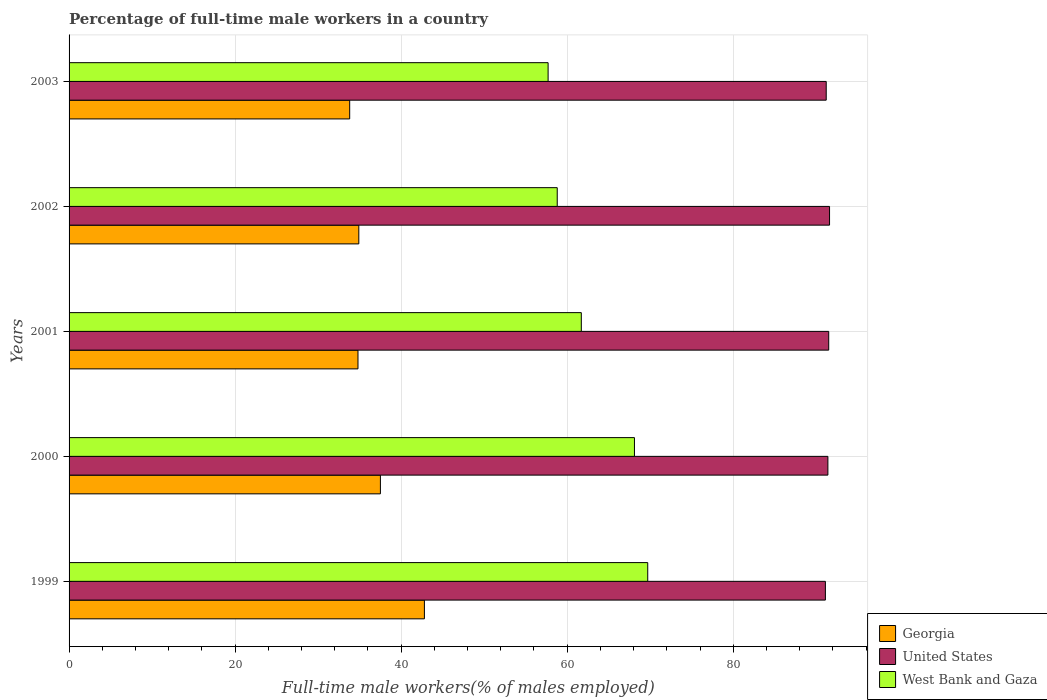How many different coloured bars are there?
Provide a short and direct response. 3. How many groups of bars are there?
Offer a very short reply. 5. How many bars are there on the 3rd tick from the top?
Make the answer very short. 3. How many bars are there on the 2nd tick from the bottom?
Offer a terse response. 3. What is the label of the 4th group of bars from the top?
Make the answer very short. 2000. In how many cases, is the number of bars for a given year not equal to the number of legend labels?
Give a very brief answer. 0. What is the percentage of full-time male workers in United States in 2001?
Ensure brevity in your answer.  91.5. Across all years, what is the maximum percentage of full-time male workers in Georgia?
Your response must be concise. 42.8. Across all years, what is the minimum percentage of full-time male workers in Georgia?
Give a very brief answer. 33.8. In which year was the percentage of full-time male workers in Georgia minimum?
Give a very brief answer. 2003. What is the total percentage of full-time male workers in West Bank and Gaza in the graph?
Offer a terse response. 316. What is the difference between the percentage of full-time male workers in United States in 2000 and that in 2002?
Keep it short and to the point. -0.2. What is the difference between the percentage of full-time male workers in Georgia in 1999 and the percentage of full-time male workers in West Bank and Gaza in 2003?
Your answer should be compact. -14.9. What is the average percentage of full-time male workers in United States per year?
Offer a terse response. 91.36. In the year 1999, what is the difference between the percentage of full-time male workers in United States and percentage of full-time male workers in Georgia?
Provide a succinct answer. 48.3. In how many years, is the percentage of full-time male workers in West Bank and Gaza greater than 84 %?
Offer a terse response. 0. What is the ratio of the percentage of full-time male workers in United States in 1999 to that in 2001?
Provide a succinct answer. 1. What is the difference between the highest and the second highest percentage of full-time male workers in United States?
Your response must be concise. 0.1. What is the difference between the highest and the lowest percentage of full-time male workers in West Bank and Gaza?
Ensure brevity in your answer.  12. In how many years, is the percentage of full-time male workers in West Bank and Gaza greater than the average percentage of full-time male workers in West Bank and Gaza taken over all years?
Ensure brevity in your answer.  2. What does the 2nd bar from the top in 1999 represents?
Your answer should be very brief. United States. What does the 1st bar from the bottom in 2000 represents?
Keep it short and to the point. Georgia. Are all the bars in the graph horizontal?
Provide a succinct answer. Yes. What is the difference between two consecutive major ticks on the X-axis?
Your answer should be very brief. 20. Are the values on the major ticks of X-axis written in scientific E-notation?
Your response must be concise. No. How many legend labels are there?
Your answer should be very brief. 3. How are the legend labels stacked?
Your answer should be compact. Vertical. What is the title of the graph?
Offer a very short reply. Percentage of full-time male workers in a country. Does "North America" appear as one of the legend labels in the graph?
Provide a succinct answer. No. What is the label or title of the X-axis?
Give a very brief answer. Full-time male workers(% of males employed). What is the Full-time male workers(% of males employed) of Georgia in 1999?
Keep it short and to the point. 42.8. What is the Full-time male workers(% of males employed) of United States in 1999?
Offer a very short reply. 91.1. What is the Full-time male workers(% of males employed) of West Bank and Gaza in 1999?
Offer a very short reply. 69.7. What is the Full-time male workers(% of males employed) of Georgia in 2000?
Give a very brief answer. 37.5. What is the Full-time male workers(% of males employed) of United States in 2000?
Offer a terse response. 91.4. What is the Full-time male workers(% of males employed) of West Bank and Gaza in 2000?
Provide a succinct answer. 68.1. What is the Full-time male workers(% of males employed) of Georgia in 2001?
Your answer should be very brief. 34.8. What is the Full-time male workers(% of males employed) of United States in 2001?
Your answer should be compact. 91.5. What is the Full-time male workers(% of males employed) of West Bank and Gaza in 2001?
Your answer should be very brief. 61.7. What is the Full-time male workers(% of males employed) of Georgia in 2002?
Your response must be concise. 34.9. What is the Full-time male workers(% of males employed) in United States in 2002?
Your answer should be very brief. 91.6. What is the Full-time male workers(% of males employed) of West Bank and Gaza in 2002?
Your answer should be very brief. 58.8. What is the Full-time male workers(% of males employed) of Georgia in 2003?
Your response must be concise. 33.8. What is the Full-time male workers(% of males employed) in United States in 2003?
Give a very brief answer. 91.2. What is the Full-time male workers(% of males employed) of West Bank and Gaza in 2003?
Offer a very short reply. 57.7. Across all years, what is the maximum Full-time male workers(% of males employed) of Georgia?
Your answer should be very brief. 42.8. Across all years, what is the maximum Full-time male workers(% of males employed) of United States?
Keep it short and to the point. 91.6. Across all years, what is the maximum Full-time male workers(% of males employed) of West Bank and Gaza?
Give a very brief answer. 69.7. Across all years, what is the minimum Full-time male workers(% of males employed) in Georgia?
Provide a short and direct response. 33.8. Across all years, what is the minimum Full-time male workers(% of males employed) in United States?
Offer a very short reply. 91.1. Across all years, what is the minimum Full-time male workers(% of males employed) of West Bank and Gaza?
Ensure brevity in your answer.  57.7. What is the total Full-time male workers(% of males employed) of Georgia in the graph?
Keep it short and to the point. 183.8. What is the total Full-time male workers(% of males employed) in United States in the graph?
Ensure brevity in your answer.  456.8. What is the total Full-time male workers(% of males employed) in West Bank and Gaza in the graph?
Keep it short and to the point. 316. What is the difference between the Full-time male workers(% of males employed) in Georgia in 1999 and that in 2000?
Keep it short and to the point. 5.3. What is the difference between the Full-time male workers(% of males employed) of United States in 1999 and that in 2000?
Ensure brevity in your answer.  -0.3. What is the difference between the Full-time male workers(% of males employed) in Georgia in 1999 and that in 2001?
Give a very brief answer. 8. What is the difference between the Full-time male workers(% of males employed) in West Bank and Gaza in 1999 and that in 2001?
Your response must be concise. 8. What is the difference between the Full-time male workers(% of males employed) of United States in 1999 and that in 2002?
Keep it short and to the point. -0.5. What is the difference between the Full-time male workers(% of males employed) in Georgia in 1999 and that in 2003?
Offer a very short reply. 9. What is the difference between the Full-time male workers(% of males employed) of United States in 1999 and that in 2003?
Provide a succinct answer. -0.1. What is the difference between the Full-time male workers(% of males employed) of United States in 2000 and that in 2003?
Your response must be concise. 0.2. What is the difference between the Full-time male workers(% of males employed) of West Bank and Gaza in 2000 and that in 2003?
Keep it short and to the point. 10.4. What is the difference between the Full-time male workers(% of males employed) in United States in 2001 and that in 2002?
Provide a short and direct response. -0.1. What is the difference between the Full-time male workers(% of males employed) of West Bank and Gaza in 2001 and that in 2002?
Keep it short and to the point. 2.9. What is the difference between the Full-time male workers(% of males employed) of Georgia in 2001 and that in 2003?
Offer a very short reply. 1. What is the difference between the Full-time male workers(% of males employed) in Georgia in 2002 and that in 2003?
Provide a short and direct response. 1.1. What is the difference between the Full-time male workers(% of males employed) of West Bank and Gaza in 2002 and that in 2003?
Provide a succinct answer. 1.1. What is the difference between the Full-time male workers(% of males employed) of Georgia in 1999 and the Full-time male workers(% of males employed) of United States in 2000?
Keep it short and to the point. -48.6. What is the difference between the Full-time male workers(% of males employed) of Georgia in 1999 and the Full-time male workers(% of males employed) of West Bank and Gaza in 2000?
Your response must be concise. -25.3. What is the difference between the Full-time male workers(% of males employed) of Georgia in 1999 and the Full-time male workers(% of males employed) of United States in 2001?
Your answer should be very brief. -48.7. What is the difference between the Full-time male workers(% of males employed) of Georgia in 1999 and the Full-time male workers(% of males employed) of West Bank and Gaza in 2001?
Your answer should be compact. -18.9. What is the difference between the Full-time male workers(% of males employed) of United States in 1999 and the Full-time male workers(% of males employed) of West Bank and Gaza in 2001?
Provide a succinct answer. 29.4. What is the difference between the Full-time male workers(% of males employed) in Georgia in 1999 and the Full-time male workers(% of males employed) in United States in 2002?
Give a very brief answer. -48.8. What is the difference between the Full-time male workers(% of males employed) in Georgia in 1999 and the Full-time male workers(% of males employed) in West Bank and Gaza in 2002?
Give a very brief answer. -16. What is the difference between the Full-time male workers(% of males employed) in United States in 1999 and the Full-time male workers(% of males employed) in West Bank and Gaza in 2002?
Your answer should be compact. 32.3. What is the difference between the Full-time male workers(% of males employed) of Georgia in 1999 and the Full-time male workers(% of males employed) of United States in 2003?
Give a very brief answer. -48.4. What is the difference between the Full-time male workers(% of males employed) of Georgia in 1999 and the Full-time male workers(% of males employed) of West Bank and Gaza in 2003?
Provide a short and direct response. -14.9. What is the difference between the Full-time male workers(% of males employed) of United States in 1999 and the Full-time male workers(% of males employed) of West Bank and Gaza in 2003?
Keep it short and to the point. 33.4. What is the difference between the Full-time male workers(% of males employed) in Georgia in 2000 and the Full-time male workers(% of males employed) in United States in 2001?
Provide a succinct answer. -54. What is the difference between the Full-time male workers(% of males employed) of Georgia in 2000 and the Full-time male workers(% of males employed) of West Bank and Gaza in 2001?
Provide a succinct answer. -24.2. What is the difference between the Full-time male workers(% of males employed) of United States in 2000 and the Full-time male workers(% of males employed) of West Bank and Gaza in 2001?
Offer a very short reply. 29.7. What is the difference between the Full-time male workers(% of males employed) in Georgia in 2000 and the Full-time male workers(% of males employed) in United States in 2002?
Your response must be concise. -54.1. What is the difference between the Full-time male workers(% of males employed) in Georgia in 2000 and the Full-time male workers(% of males employed) in West Bank and Gaza in 2002?
Keep it short and to the point. -21.3. What is the difference between the Full-time male workers(% of males employed) of United States in 2000 and the Full-time male workers(% of males employed) of West Bank and Gaza in 2002?
Your answer should be compact. 32.6. What is the difference between the Full-time male workers(% of males employed) of Georgia in 2000 and the Full-time male workers(% of males employed) of United States in 2003?
Your answer should be compact. -53.7. What is the difference between the Full-time male workers(% of males employed) in Georgia in 2000 and the Full-time male workers(% of males employed) in West Bank and Gaza in 2003?
Give a very brief answer. -20.2. What is the difference between the Full-time male workers(% of males employed) in United States in 2000 and the Full-time male workers(% of males employed) in West Bank and Gaza in 2003?
Ensure brevity in your answer.  33.7. What is the difference between the Full-time male workers(% of males employed) of Georgia in 2001 and the Full-time male workers(% of males employed) of United States in 2002?
Provide a short and direct response. -56.8. What is the difference between the Full-time male workers(% of males employed) of Georgia in 2001 and the Full-time male workers(% of males employed) of West Bank and Gaza in 2002?
Your answer should be compact. -24. What is the difference between the Full-time male workers(% of males employed) of United States in 2001 and the Full-time male workers(% of males employed) of West Bank and Gaza in 2002?
Offer a very short reply. 32.7. What is the difference between the Full-time male workers(% of males employed) in Georgia in 2001 and the Full-time male workers(% of males employed) in United States in 2003?
Provide a succinct answer. -56.4. What is the difference between the Full-time male workers(% of males employed) in Georgia in 2001 and the Full-time male workers(% of males employed) in West Bank and Gaza in 2003?
Give a very brief answer. -22.9. What is the difference between the Full-time male workers(% of males employed) of United States in 2001 and the Full-time male workers(% of males employed) of West Bank and Gaza in 2003?
Give a very brief answer. 33.8. What is the difference between the Full-time male workers(% of males employed) of Georgia in 2002 and the Full-time male workers(% of males employed) of United States in 2003?
Your answer should be compact. -56.3. What is the difference between the Full-time male workers(% of males employed) in Georgia in 2002 and the Full-time male workers(% of males employed) in West Bank and Gaza in 2003?
Keep it short and to the point. -22.8. What is the difference between the Full-time male workers(% of males employed) of United States in 2002 and the Full-time male workers(% of males employed) of West Bank and Gaza in 2003?
Your answer should be very brief. 33.9. What is the average Full-time male workers(% of males employed) of Georgia per year?
Keep it short and to the point. 36.76. What is the average Full-time male workers(% of males employed) in United States per year?
Offer a terse response. 91.36. What is the average Full-time male workers(% of males employed) of West Bank and Gaza per year?
Offer a very short reply. 63.2. In the year 1999, what is the difference between the Full-time male workers(% of males employed) of Georgia and Full-time male workers(% of males employed) of United States?
Offer a very short reply. -48.3. In the year 1999, what is the difference between the Full-time male workers(% of males employed) in Georgia and Full-time male workers(% of males employed) in West Bank and Gaza?
Make the answer very short. -26.9. In the year 1999, what is the difference between the Full-time male workers(% of males employed) in United States and Full-time male workers(% of males employed) in West Bank and Gaza?
Offer a terse response. 21.4. In the year 2000, what is the difference between the Full-time male workers(% of males employed) of Georgia and Full-time male workers(% of males employed) of United States?
Provide a short and direct response. -53.9. In the year 2000, what is the difference between the Full-time male workers(% of males employed) in Georgia and Full-time male workers(% of males employed) in West Bank and Gaza?
Keep it short and to the point. -30.6. In the year 2000, what is the difference between the Full-time male workers(% of males employed) of United States and Full-time male workers(% of males employed) of West Bank and Gaza?
Offer a very short reply. 23.3. In the year 2001, what is the difference between the Full-time male workers(% of males employed) in Georgia and Full-time male workers(% of males employed) in United States?
Provide a short and direct response. -56.7. In the year 2001, what is the difference between the Full-time male workers(% of males employed) of Georgia and Full-time male workers(% of males employed) of West Bank and Gaza?
Give a very brief answer. -26.9. In the year 2001, what is the difference between the Full-time male workers(% of males employed) in United States and Full-time male workers(% of males employed) in West Bank and Gaza?
Ensure brevity in your answer.  29.8. In the year 2002, what is the difference between the Full-time male workers(% of males employed) in Georgia and Full-time male workers(% of males employed) in United States?
Make the answer very short. -56.7. In the year 2002, what is the difference between the Full-time male workers(% of males employed) of Georgia and Full-time male workers(% of males employed) of West Bank and Gaza?
Provide a short and direct response. -23.9. In the year 2002, what is the difference between the Full-time male workers(% of males employed) of United States and Full-time male workers(% of males employed) of West Bank and Gaza?
Make the answer very short. 32.8. In the year 2003, what is the difference between the Full-time male workers(% of males employed) in Georgia and Full-time male workers(% of males employed) in United States?
Your answer should be compact. -57.4. In the year 2003, what is the difference between the Full-time male workers(% of males employed) in Georgia and Full-time male workers(% of males employed) in West Bank and Gaza?
Provide a short and direct response. -23.9. In the year 2003, what is the difference between the Full-time male workers(% of males employed) of United States and Full-time male workers(% of males employed) of West Bank and Gaza?
Keep it short and to the point. 33.5. What is the ratio of the Full-time male workers(% of males employed) of Georgia in 1999 to that in 2000?
Keep it short and to the point. 1.14. What is the ratio of the Full-time male workers(% of males employed) of West Bank and Gaza in 1999 to that in 2000?
Give a very brief answer. 1.02. What is the ratio of the Full-time male workers(% of males employed) of Georgia in 1999 to that in 2001?
Offer a very short reply. 1.23. What is the ratio of the Full-time male workers(% of males employed) in West Bank and Gaza in 1999 to that in 2001?
Keep it short and to the point. 1.13. What is the ratio of the Full-time male workers(% of males employed) in Georgia in 1999 to that in 2002?
Provide a succinct answer. 1.23. What is the ratio of the Full-time male workers(% of males employed) in West Bank and Gaza in 1999 to that in 2002?
Offer a very short reply. 1.19. What is the ratio of the Full-time male workers(% of males employed) in Georgia in 1999 to that in 2003?
Provide a short and direct response. 1.27. What is the ratio of the Full-time male workers(% of males employed) in United States in 1999 to that in 2003?
Give a very brief answer. 1. What is the ratio of the Full-time male workers(% of males employed) in West Bank and Gaza in 1999 to that in 2003?
Provide a short and direct response. 1.21. What is the ratio of the Full-time male workers(% of males employed) of Georgia in 2000 to that in 2001?
Offer a terse response. 1.08. What is the ratio of the Full-time male workers(% of males employed) of United States in 2000 to that in 2001?
Your answer should be very brief. 1. What is the ratio of the Full-time male workers(% of males employed) in West Bank and Gaza in 2000 to that in 2001?
Offer a very short reply. 1.1. What is the ratio of the Full-time male workers(% of males employed) of Georgia in 2000 to that in 2002?
Provide a short and direct response. 1.07. What is the ratio of the Full-time male workers(% of males employed) in United States in 2000 to that in 2002?
Keep it short and to the point. 1. What is the ratio of the Full-time male workers(% of males employed) in West Bank and Gaza in 2000 to that in 2002?
Your response must be concise. 1.16. What is the ratio of the Full-time male workers(% of males employed) in Georgia in 2000 to that in 2003?
Give a very brief answer. 1.11. What is the ratio of the Full-time male workers(% of males employed) in West Bank and Gaza in 2000 to that in 2003?
Your response must be concise. 1.18. What is the ratio of the Full-time male workers(% of males employed) in West Bank and Gaza in 2001 to that in 2002?
Give a very brief answer. 1.05. What is the ratio of the Full-time male workers(% of males employed) of Georgia in 2001 to that in 2003?
Make the answer very short. 1.03. What is the ratio of the Full-time male workers(% of males employed) in United States in 2001 to that in 2003?
Offer a very short reply. 1. What is the ratio of the Full-time male workers(% of males employed) in West Bank and Gaza in 2001 to that in 2003?
Make the answer very short. 1.07. What is the ratio of the Full-time male workers(% of males employed) in Georgia in 2002 to that in 2003?
Your answer should be very brief. 1.03. What is the ratio of the Full-time male workers(% of males employed) of United States in 2002 to that in 2003?
Your answer should be compact. 1. What is the ratio of the Full-time male workers(% of males employed) of West Bank and Gaza in 2002 to that in 2003?
Give a very brief answer. 1.02. What is the difference between the highest and the second highest Full-time male workers(% of males employed) in United States?
Provide a succinct answer. 0.1. What is the difference between the highest and the second highest Full-time male workers(% of males employed) in West Bank and Gaza?
Your response must be concise. 1.6. What is the difference between the highest and the lowest Full-time male workers(% of males employed) of United States?
Keep it short and to the point. 0.5. 